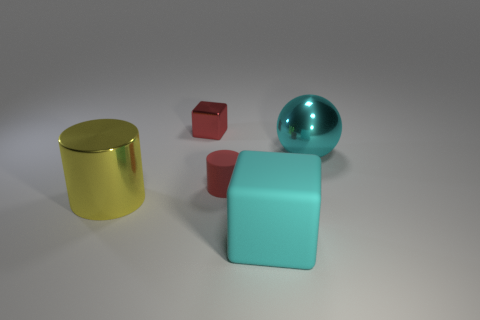Add 1 tiny purple metal objects. How many objects exist? 6 Subtract all yellow cylinders. How many cylinders are left? 1 Subtract all cylinders. How many objects are left? 3 Subtract 2 cylinders. How many cylinders are left? 0 Add 2 big brown cylinders. How many big brown cylinders exist? 2 Subtract 1 red cylinders. How many objects are left? 4 Subtract all red blocks. Subtract all cyan spheres. How many blocks are left? 1 Subtract all yellow metal things. Subtract all metallic cylinders. How many objects are left? 3 Add 3 big yellow cylinders. How many big yellow cylinders are left? 4 